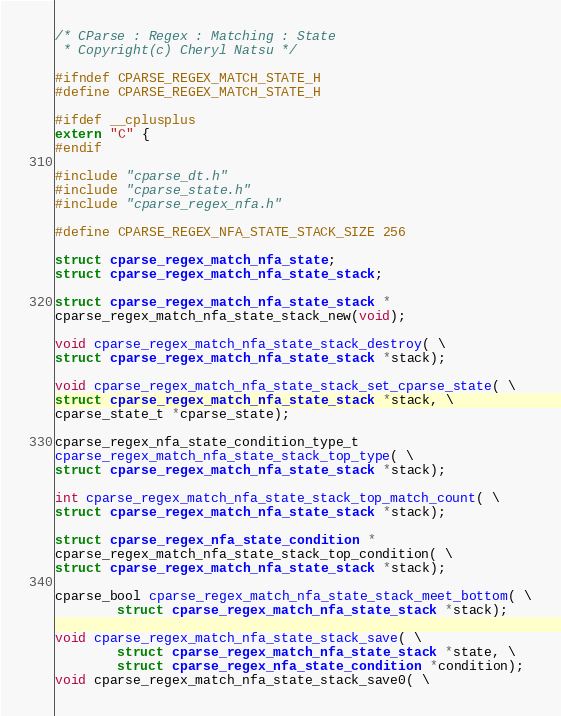Convert code to text. <code><loc_0><loc_0><loc_500><loc_500><_C_>/* CParse : Regex : Matching : State
 * Copyright(c) Cheryl Natsu */

#ifndef CPARSE_REGEX_MATCH_STATE_H
#define CPARSE_REGEX_MATCH_STATE_H

#ifdef __cplusplus
extern "C" {
#endif

#include "cparse_dt.h"
#include "cparse_state.h"
#include "cparse_regex_nfa.h"

#define CPARSE_REGEX_NFA_STATE_STACK_SIZE 256

struct cparse_regex_match_nfa_state;
struct cparse_regex_match_nfa_state_stack;

struct cparse_regex_match_nfa_state_stack *
cparse_regex_match_nfa_state_stack_new(void);

void cparse_regex_match_nfa_state_stack_destroy( \
struct cparse_regex_match_nfa_state_stack *stack);

void cparse_regex_match_nfa_state_stack_set_cparse_state( \
struct cparse_regex_match_nfa_state_stack *stack, \
cparse_state_t *cparse_state);

cparse_regex_nfa_state_condition_type_t
cparse_regex_match_nfa_state_stack_top_type( \
struct cparse_regex_match_nfa_state_stack *stack);

int cparse_regex_match_nfa_state_stack_top_match_count( \
struct cparse_regex_match_nfa_state_stack *stack);

struct cparse_regex_nfa_state_condition *
cparse_regex_match_nfa_state_stack_top_condition( \
struct cparse_regex_match_nfa_state_stack *stack);

cparse_bool cparse_regex_match_nfa_state_stack_meet_bottom( \
        struct cparse_regex_match_nfa_state_stack *stack);

void cparse_regex_match_nfa_state_stack_save( \
        struct cparse_regex_match_nfa_state_stack *state, \
        struct cparse_regex_nfa_state_condition *condition);
void cparse_regex_match_nfa_state_stack_save0( \</code> 